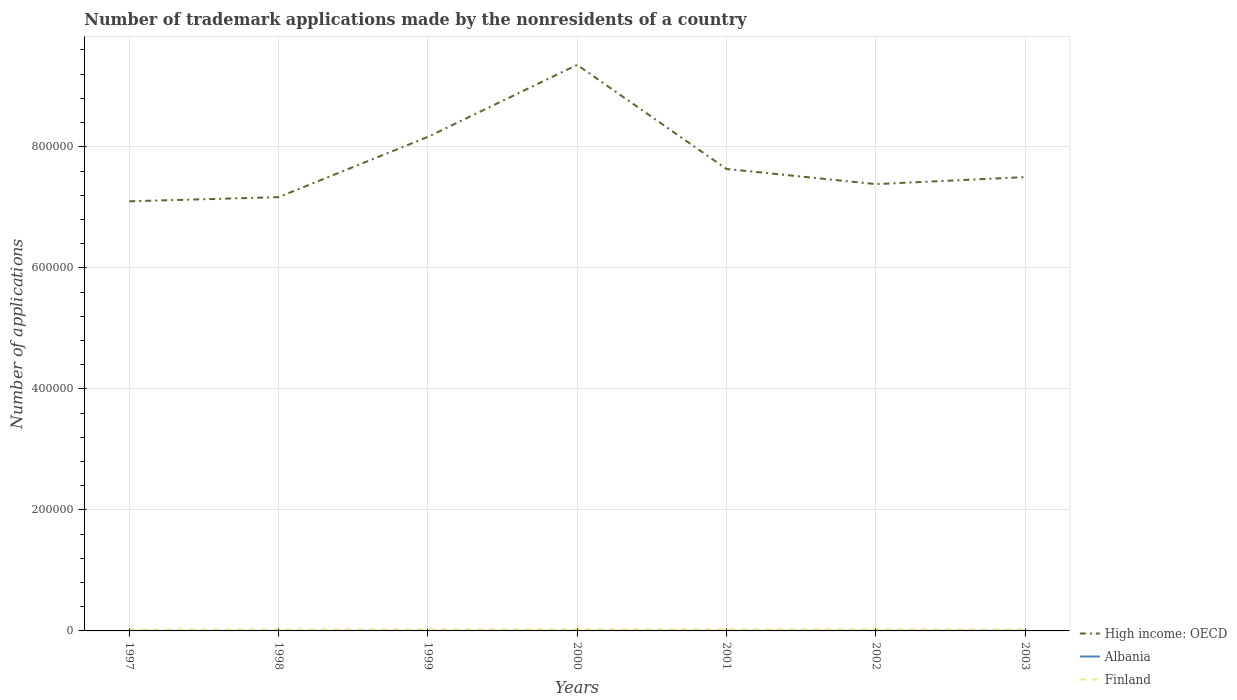How many different coloured lines are there?
Provide a succinct answer. 3. Across all years, what is the maximum number of trademark applications made by the nonresidents in Finland?
Offer a terse response. 2247. In which year was the number of trademark applications made by the nonresidents in Finland maximum?
Offer a terse response. 1997. What is the total number of trademark applications made by the nonresidents in High income: OECD in the graph?
Your answer should be compact. -2.25e+05. What is the difference between the highest and the second highest number of trademark applications made by the nonresidents in Albania?
Your answer should be compact. 115. Is the number of trademark applications made by the nonresidents in High income: OECD strictly greater than the number of trademark applications made by the nonresidents in Albania over the years?
Your answer should be compact. No. How many lines are there?
Offer a very short reply. 3. How many years are there in the graph?
Make the answer very short. 7. What is the difference between two consecutive major ticks on the Y-axis?
Ensure brevity in your answer.  2.00e+05. Are the values on the major ticks of Y-axis written in scientific E-notation?
Ensure brevity in your answer.  No. Does the graph contain grids?
Your answer should be compact. Yes. Where does the legend appear in the graph?
Your answer should be very brief. Bottom right. How many legend labels are there?
Provide a short and direct response. 3. What is the title of the graph?
Offer a terse response. Number of trademark applications made by the nonresidents of a country. Does "Kyrgyz Republic" appear as one of the legend labels in the graph?
Provide a succinct answer. No. What is the label or title of the X-axis?
Provide a succinct answer. Years. What is the label or title of the Y-axis?
Give a very brief answer. Number of applications. What is the Number of applications of High income: OECD in 1997?
Your answer should be compact. 7.10e+05. What is the Number of applications in Albania in 1997?
Your answer should be very brief. 36. What is the Number of applications of Finland in 1997?
Give a very brief answer. 2247. What is the Number of applications of High income: OECD in 1998?
Keep it short and to the point. 7.17e+05. What is the Number of applications of Finland in 1998?
Your answer should be compact. 2370. What is the Number of applications in High income: OECD in 1999?
Your response must be concise. 8.16e+05. What is the Number of applications in Albania in 1999?
Your response must be concise. 17. What is the Number of applications in Finland in 1999?
Your response must be concise. 2620. What is the Number of applications of High income: OECD in 2000?
Your answer should be very brief. 9.35e+05. What is the Number of applications in Albania in 2000?
Give a very brief answer. 32. What is the Number of applications of Finland in 2000?
Your answer should be compact. 2906. What is the Number of applications of High income: OECD in 2001?
Your answer should be very brief. 7.63e+05. What is the Number of applications in Finland in 2001?
Provide a succinct answer. 2879. What is the Number of applications in High income: OECD in 2002?
Provide a succinct answer. 7.38e+05. What is the Number of applications in Albania in 2002?
Keep it short and to the point. 106. What is the Number of applications of Finland in 2002?
Give a very brief answer. 2830. What is the Number of applications in High income: OECD in 2003?
Give a very brief answer. 7.50e+05. What is the Number of applications of Albania in 2003?
Keep it short and to the point. 132. What is the Number of applications in Finland in 2003?
Your response must be concise. 2456. Across all years, what is the maximum Number of applications of High income: OECD?
Your response must be concise. 9.35e+05. Across all years, what is the maximum Number of applications in Albania?
Provide a succinct answer. 132. Across all years, what is the maximum Number of applications in Finland?
Keep it short and to the point. 2906. Across all years, what is the minimum Number of applications of High income: OECD?
Your answer should be compact. 7.10e+05. Across all years, what is the minimum Number of applications in Finland?
Your answer should be very brief. 2247. What is the total Number of applications in High income: OECD in the graph?
Give a very brief answer. 5.43e+06. What is the total Number of applications of Albania in the graph?
Provide a succinct answer. 404. What is the total Number of applications in Finland in the graph?
Offer a very short reply. 1.83e+04. What is the difference between the Number of applications in High income: OECD in 1997 and that in 1998?
Make the answer very short. -6853. What is the difference between the Number of applications of Finland in 1997 and that in 1998?
Offer a very short reply. -123. What is the difference between the Number of applications in High income: OECD in 1997 and that in 1999?
Your answer should be compact. -1.06e+05. What is the difference between the Number of applications of Finland in 1997 and that in 1999?
Make the answer very short. -373. What is the difference between the Number of applications of High income: OECD in 1997 and that in 2000?
Keep it short and to the point. -2.25e+05. What is the difference between the Number of applications in Albania in 1997 and that in 2000?
Offer a terse response. 4. What is the difference between the Number of applications of Finland in 1997 and that in 2000?
Your answer should be very brief. -659. What is the difference between the Number of applications of High income: OECD in 1997 and that in 2001?
Your response must be concise. -5.35e+04. What is the difference between the Number of applications of Finland in 1997 and that in 2001?
Offer a terse response. -632. What is the difference between the Number of applications in High income: OECD in 1997 and that in 2002?
Provide a short and direct response. -2.84e+04. What is the difference between the Number of applications of Albania in 1997 and that in 2002?
Ensure brevity in your answer.  -70. What is the difference between the Number of applications in Finland in 1997 and that in 2002?
Provide a succinct answer. -583. What is the difference between the Number of applications in High income: OECD in 1997 and that in 2003?
Your answer should be compact. -4.00e+04. What is the difference between the Number of applications in Albania in 1997 and that in 2003?
Offer a very short reply. -96. What is the difference between the Number of applications of Finland in 1997 and that in 2003?
Provide a succinct answer. -209. What is the difference between the Number of applications of High income: OECD in 1998 and that in 1999?
Offer a terse response. -9.96e+04. What is the difference between the Number of applications in Albania in 1998 and that in 1999?
Make the answer very short. 10. What is the difference between the Number of applications in Finland in 1998 and that in 1999?
Offer a terse response. -250. What is the difference between the Number of applications in High income: OECD in 1998 and that in 2000?
Keep it short and to the point. -2.19e+05. What is the difference between the Number of applications in Albania in 1998 and that in 2000?
Your answer should be very brief. -5. What is the difference between the Number of applications of Finland in 1998 and that in 2000?
Provide a short and direct response. -536. What is the difference between the Number of applications in High income: OECD in 1998 and that in 2001?
Provide a short and direct response. -4.66e+04. What is the difference between the Number of applications in Albania in 1998 and that in 2001?
Offer a terse response. -27. What is the difference between the Number of applications in Finland in 1998 and that in 2001?
Keep it short and to the point. -509. What is the difference between the Number of applications in High income: OECD in 1998 and that in 2002?
Make the answer very short. -2.16e+04. What is the difference between the Number of applications in Albania in 1998 and that in 2002?
Your answer should be very brief. -79. What is the difference between the Number of applications of Finland in 1998 and that in 2002?
Your response must be concise. -460. What is the difference between the Number of applications of High income: OECD in 1998 and that in 2003?
Make the answer very short. -3.32e+04. What is the difference between the Number of applications of Albania in 1998 and that in 2003?
Provide a succinct answer. -105. What is the difference between the Number of applications of Finland in 1998 and that in 2003?
Keep it short and to the point. -86. What is the difference between the Number of applications in High income: OECD in 1999 and that in 2000?
Your response must be concise. -1.19e+05. What is the difference between the Number of applications in Albania in 1999 and that in 2000?
Your answer should be very brief. -15. What is the difference between the Number of applications in Finland in 1999 and that in 2000?
Your answer should be very brief. -286. What is the difference between the Number of applications in High income: OECD in 1999 and that in 2001?
Offer a terse response. 5.30e+04. What is the difference between the Number of applications in Albania in 1999 and that in 2001?
Your answer should be very brief. -37. What is the difference between the Number of applications in Finland in 1999 and that in 2001?
Your response must be concise. -259. What is the difference between the Number of applications of High income: OECD in 1999 and that in 2002?
Keep it short and to the point. 7.80e+04. What is the difference between the Number of applications of Albania in 1999 and that in 2002?
Give a very brief answer. -89. What is the difference between the Number of applications in Finland in 1999 and that in 2002?
Keep it short and to the point. -210. What is the difference between the Number of applications in High income: OECD in 1999 and that in 2003?
Make the answer very short. 6.64e+04. What is the difference between the Number of applications in Albania in 1999 and that in 2003?
Provide a succinct answer. -115. What is the difference between the Number of applications of Finland in 1999 and that in 2003?
Your response must be concise. 164. What is the difference between the Number of applications in High income: OECD in 2000 and that in 2001?
Give a very brief answer. 1.72e+05. What is the difference between the Number of applications in Finland in 2000 and that in 2001?
Offer a terse response. 27. What is the difference between the Number of applications of High income: OECD in 2000 and that in 2002?
Your response must be concise. 1.97e+05. What is the difference between the Number of applications in Albania in 2000 and that in 2002?
Your answer should be very brief. -74. What is the difference between the Number of applications in Finland in 2000 and that in 2002?
Provide a short and direct response. 76. What is the difference between the Number of applications in High income: OECD in 2000 and that in 2003?
Offer a terse response. 1.85e+05. What is the difference between the Number of applications in Albania in 2000 and that in 2003?
Offer a very short reply. -100. What is the difference between the Number of applications of Finland in 2000 and that in 2003?
Your response must be concise. 450. What is the difference between the Number of applications in High income: OECD in 2001 and that in 2002?
Give a very brief answer. 2.51e+04. What is the difference between the Number of applications of Albania in 2001 and that in 2002?
Offer a terse response. -52. What is the difference between the Number of applications in High income: OECD in 2001 and that in 2003?
Make the answer very short. 1.35e+04. What is the difference between the Number of applications in Albania in 2001 and that in 2003?
Your answer should be very brief. -78. What is the difference between the Number of applications in Finland in 2001 and that in 2003?
Your answer should be compact. 423. What is the difference between the Number of applications in High income: OECD in 2002 and that in 2003?
Make the answer very short. -1.16e+04. What is the difference between the Number of applications in Albania in 2002 and that in 2003?
Your answer should be very brief. -26. What is the difference between the Number of applications in Finland in 2002 and that in 2003?
Your response must be concise. 374. What is the difference between the Number of applications of High income: OECD in 1997 and the Number of applications of Albania in 1998?
Offer a terse response. 7.10e+05. What is the difference between the Number of applications of High income: OECD in 1997 and the Number of applications of Finland in 1998?
Your response must be concise. 7.08e+05. What is the difference between the Number of applications in Albania in 1997 and the Number of applications in Finland in 1998?
Offer a very short reply. -2334. What is the difference between the Number of applications in High income: OECD in 1997 and the Number of applications in Albania in 1999?
Your response must be concise. 7.10e+05. What is the difference between the Number of applications in High income: OECD in 1997 and the Number of applications in Finland in 1999?
Keep it short and to the point. 7.07e+05. What is the difference between the Number of applications of Albania in 1997 and the Number of applications of Finland in 1999?
Make the answer very short. -2584. What is the difference between the Number of applications in High income: OECD in 1997 and the Number of applications in Albania in 2000?
Make the answer very short. 7.10e+05. What is the difference between the Number of applications in High income: OECD in 1997 and the Number of applications in Finland in 2000?
Provide a short and direct response. 7.07e+05. What is the difference between the Number of applications of Albania in 1997 and the Number of applications of Finland in 2000?
Offer a very short reply. -2870. What is the difference between the Number of applications of High income: OECD in 1997 and the Number of applications of Albania in 2001?
Give a very brief answer. 7.10e+05. What is the difference between the Number of applications in High income: OECD in 1997 and the Number of applications in Finland in 2001?
Your answer should be very brief. 7.07e+05. What is the difference between the Number of applications in Albania in 1997 and the Number of applications in Finland in 2001?
Provide a succinct answer. -2843. What is the difference between the Number of applications in High income: OECD in 1997 and the Number of applications in Albania in 2002?
Your answer should be very brief. 7.10e+05. What is the difference between the Number of applications of High income: OECD in 1997 and the Number of applications of Finland in 2002?
Give a very brief answer. 7.07e+05. What is the difference between the Number of applications in Albania in 1997 and the Number of applications in Finland in 2002?
Provide a succinct answer. -2794. What is the difference between the Number of applications of High income: OECD in 1997 and the Number of applications of Albania in 2003?
Offer a very short reply. 7.10e+05. What is the difference between the Number of applications of High income: OECD in 1997 and the Number of applications of Finland in 2003?
Ensure brevity in your answer.  7.07e+05. What is the difference between the Number of applications in Albania in 1997 and the Number of applications in Finland in 2003?
Your answer should be very brief. -2420. What is the difference between the Number of applications in High income: OECD in 1998 and the Number of applications in Albania in 1999?
Your answer should be compact. 7.17e+05. What is the difference between the Number of applications of High income: OECD in 1998 and the Number of applications of Finland in 1999?
Your response must be concise. 7.14e+05. What is the difference between the Number of applications of Albania in 1998 and the Number of applications of Finland in 1999?
Your answer should be compact. -2593. What is the difference between the Number of applications of High income: OECD in 1998 and the Number of applications of Albania in 2000?
Provide a short and direct response. 7.17e+05. What is the difference between the Number of applications in High income: OECD in 1998 and the Number of applications in Finland in 2000?
Offer a terse response. 7.14e+05. What is the difference between the Number of applications in Albania in 1998 and the Number of applications in Finland in 2000?
Keep it short and to the point. -2879. What is the difference between the Number of applications of High income: OECD in 1998 and the Number of applications of Albania in 2001?
Your answer should be very brief. 7.17e+05. What is the difference between the Number of applications of High income: OECD in 1998 and the Number of applications of Finland in 2001?
Make the answer very short. 7.14e+05. What is the difference between the Number of applications of Albania in 1998 and the Number of applications of Finland in 2001?
Provide a succinct answer. -2852. What is the difference between the Number of applications in High income: OECD in 1998 and the Number of applications in Albania in 2002?
Your answer should be compact. 7.17e+05. What is the difference between the Number of applications of High income: OECD in 1998 and the Number of applications of Finland in 2002?
Your answer should be very brief. 7.14e+05. What is the difference between the Number of applications in Albania in 1998 and the Number of applications in Finland in 2002?
Your answer should be compact. -2803. What is the difference between the Number of applications in High income: OECD in 1998 and the Number of applications in Albania in 2003?
Provide a succinct answer. 7.17e+05. What is the difference between the Number of applications in High income: OECD in 1998 and the Number of applications in Finland in 2003?
Your answer should be compact. 7.14e+05. What is the difference between the Number of applications of Albania in 1998 and the Number of applications of Finland in 2003?
Give a very brief answer. -2429. What is the difference between the Number of applications in High income: OECD in 1999 and the Number of applications in Albania in 2000?
Provide a short and direct response. 8.16e+05. What is the difference between the Number of applications in High income: OECD in 1999 and the Number of applications in Finland in 2000?
Offer a terse response. 8.13e+05. What is the difference between the Number of applications in Albania in 1999 and the Number of applications in Finland in 2000?
Ensure brevity in your answer.  -2889. What is the difference between the Number of applications in High income: OECD in 1999 and the Number of applications in Albania in 2001?
Ensure brevity in your answer.  8.16e+05. What is the difference between the Number of applications in High income: OECD in 1999 and the Number of applications in Finland in 2001?
Give a very brief answer. 8.14e+05. What is the difference between the Number of applications of Albania in 1999 and the Number of applications of Finland in 2001?
Provide a succinct answer. -2862. What is the difference between the Number of applications in High income: OECD in 1999 and the Number of applications in Albania in 2002?
Make the answer very short. 8.16e+05. What is the difference between the Number of applications of High income: OECD in 1999 and the Number of applications of Finland in 2002?
Keep it short and to the point. 8.14e+05. What is the difference between the Number of applications of Albania in 1999 and the Number of applications of Finland in 2002?
Offer a very short reply. -2813. What is the difference between the Number of applications in High income: OECD in 1999 and the Number of applications in Albania in 2003?
Give a very brief answer. 8.16e+05. What is the difference between the Number of applications in High income: OECD in 1999 and the Number of applications in Finland in 2003?
Make the answer very short. 8.14e+05. What is the difference between the Number of applications of Albania in 1999 and the Number of applications of Finland in 2003?
Your answer should be very brief. -2439. What is the difference between the Number of applications in High income: OECD in 2000 and the Number of applications in Albania in 2001?
Make the answer very short. 9.35e+05. What is the difference between the Number of applications in High income: OECD in 2000 and the Number of applications in Finland in 2001?
Offer a terse response. 9.33e+05. What is the difference between the Number of applications of Albania in 2000 and the Number of applications of Finland in 2001?
Your answer should be compact. -2847. What is the difference between the Number of applications of High income: OECD in 2000 and the Number of applications of Albania in 2002?
Make the answer very short. 9.35e+05. What is the difference between the Number of applications in High income: OECD in 2000 and the Number of applications in Finland in 2002?
Your answer should be very brief. 9.33e+05. What is the difference between the Number of applications of Albania in 2000 and the Number of applications of Finland in 2002?
Provide a short and direct response. -2798. What is the difference between the Number of applications in High income: OECD in 2000 and the Number of applications in Albania in 2003?
Offer a terse response. 9.35e+05. What is the difference between the Number of applications in High income: OECD in 2000 and the Number of applications in Finland in 2003?
Your answer should be compact. 9.33e+05. What is the difference between the Number of applications in Albania in 2000 and the Number of applications in Finland in 2003?
Make the answer very short. -2424. What is the difference between the Number of applications in High income: OECD in 2001 and the Number of applications in Albania in 2002?
Offer a terse response. 7.63e+05. What is the difference between the Number of applications of High income: OECD in 2001 and the Number of applications of Finland in 2002?
Offer a very short reply. 7.61e+05. What is the difference between the Number of applications in Albania in 2001 and the Number of applications in Finland in 2002?
Your response must be concise. -2776. What is the difference between the Number of applications of High income: OECD in 2001 and the Number of applications of Albania in 2003?
Make the answer very short. 7.63e+05. What is the difference between the Number of applications of High income: OECD in 2001 and the Number of applications of Finland in 2003?
Your answer should be very brief. 7.61e+05. What is the difference between the Number of applications of Albania in 2001 and the Number of applications of Finland in 2003?
Give a very brief answer. -2402. What is the difference between the Number of applications of High income: OECD in 2002 and the Number of applications of Albania in 2003?
Provide a short and direct response. 7.38e+05. What is the difference between the Number of applications of High income: OECD in 2002 and the Number of applications of Finland in 2003?
Your response must be concise. 7.36e+05. What is the difference between the Number of applications in Albania in 2002 and the Number of applications in Finland in 2003?
Offer a very short reply. -2350. What is the average Number of applications in High income: OECD per year?
Give a very brief answer. 7.76e+05. What is the average Number of applications in Albania per year?
Your response must be concise. 57.71. What is the average Number of applications of Finland per year?
Give a very brief answer. 2615.43. In the year 1997, what is the difference between the Number of applications of High income: OECD and Number of applications of Albania?
Make the answer very short. 7.10e+05. In the year 1997, what is the difference between the Number of applications in High income: OECD and Number of applications in Finland?
Your answer should be compact. 7.08e+05. In the year 1997, what is the difference between the Number of applications of Albania and Number of applications of Finland?
Your response must be concise. -2211. In the year 1998, what is the difference between the Number of applications of High income: OECD and Number of applications of Albania?
Offer a very short reply. 7.17e+05. In the year 1998, what is the difference between the Number of applications of High income: OECD and Number of applications of Finland?
Your response must be concise. 7.14e+05. In the year 1998, what is the difference between the Number of applications of Albania and Number of applications of Finland?
Provide a short and direct response. -2343. In the year 1999, what is the difference between the Number of applications of High income: OECD and Number of applications of Albania?
Make the answer very short. 8.16e+05. In the year 1999, what is the difference between the Number of applications of High income: OECD and Number of applications of Finland?
Your answer should be very brief. 8.14e+05. In the year 1999, what is the difference between the Number of applications in Albania and Number of applications in Finland?
Provide a succinct answer. -2603. In the year 2000, what is the difference between the Number of applications of High income: OECD and Number of applications of Albania?
Offer a very short reply. 9.35e+05. In the year 2000, what is the difference between the Number of applications in High income: OECD and Number of applications in Finland?
Offer a terse response. 9.32e+05. In the year 2000, what is the difference between the Number of applications of Albania and Number of applications of Finland?
Give a very brief answer. -2874. In the year 2001, what is the difference between the Number of applications in High income: OECD and Number of applications in Albania?
Ensure brevity in your answer.  7.63e+05. In the year 2001, what is the difference between the Number of applications of High income: OECD and Number of applications of Finland?
Provide a short and direct response. 7.61e+05. In the year 2001, what is the difference between the Number of applications in Albania and Number of applications in Finland?
Offer a terse response. -2825. In the year 2002, what is the difference between the Number of applications of High income: OECD and Number of applications of Albania?
Your response must be concise. 7.38e+05. In the year 2002, what is the difference between the Number of applications in High income: OECD and Number of applications in Finland?
Make the answer very short. 7.36e+05. In the year 2002, what is the difference between the Number of applications of Albania and Number of applications of Finland?
Your answer should be very brief. -2724. In the year 2003, what is the difference between the Number of applications of High income: OECD and Number of applications of Albania?
Make the answer very short. 7.50e+05. In the year 2003, what is the difference between the Number of applications of High income: OECD and Number of applications of Finland?
Make the answer very short. 7.47e+05. In the year 2003, what is the difference between the Number of applications in Albania and Number of applications in Finland?
Your answer should be very brief. -2324. What is the ratio of the Number of applications in High income: OECD in 1997 to that in 1998?
Your answer should be compact. 0.99. What is the ratio of the Number of applications of Albania in 1997 to that in 1998?
Ensure brevity in your answer.  1.33. What is the ratio of the Number of applications of Finland in 1997 to that in 1998?
Keep it short and to the point. 0.95. What is the ratio of the Number of applications of High income: OECD in 1997 to that in 1999?
Give a very brief answer. 0.87. What is the ratio of the Number of applications in Albania in 1997 to that in 1999?
Make the answer very short. 2.12. What is the ratio of the Number of applications of Finland in 1997 to that in 1999?
Your answer should be compact. 0.86. What is the ratio of the Number of applications in High income: OECD in 1997 to that in 2000?
Offer a terse response. 0.76. What is the ratio of the Number of applications in Finland in 1997 to that in 2000?
Offer a terse response. 0.77. What is the ratio of the Number of applications in Albania in 1997 to that in 2001?
Offer a very short reply. 0.67. What is the ratio of the Number of applications in Finland in 1997 to that in 2001?
Make the answer very short. 0.78. What is the ratio of the Number of applications in High income: OECD in 1997 to that in 2002?
Offer a terse response. 0.96. What is the ratio of the Number of applications of Albania in 1997 to that in 2002?
Ensure brevity in your answer.  0.34. What is the ratio of the Number of applications in Finland in 1997 to that in 2002?
Give a very brief answer. 0.79. What is the ratio of the Number of applications of High income: OECD in 1997 to that in 2003?
Your response must be concise. 0.95. What is the ratio of the Number of applications of Albania in 1997 to that in 2003?
Offer a very short reply. 0.27. What is the ratio of the Number of applications in Finland in 1997 to that in 2003?
Provide a succinct answer. 0.91. What is the ratio of the Number of applications in High income: OECD in 1998 to that in 1999?
Ensure brevity in your answer.  0.88. What is the ratio of the Number of applications in Albania in 1998 to that in 1999?
Give a very brief answer. 1.59. What is the ratio of the Number of applications in Finland in 1998 to that in 1999?
Your answer should be very brief. 0.9. What is the ratio of the Number of applications in High income: OECD in 1998 to that in 2000?
Your answer should be very brief. 0.77. What is the ratio of the Number of applications of Albania in 1998 to that in 2000?
Keep it short and to the point. 0.84. What is the ratio of the Number of applications in Finland in 1998 to that in 2000?
Make the answer very short. 0.82. What is the ratio of the Number of applications in High income: OECD in 1998 to that in 2001?
Your answer should be very brief. 0.94. What is the ratio of the Number of applications in Albania in 1998 to that in 2001?
Your answer should be compact. 0.5. What is the ratio of the Number of applications of Finland in 1998 to that in 2001?
Make the answer very short. 0.82. What is the ratio of the Number of applications of High income: OECD in 1998 to that in 2002?
Your response must be concise. 0.97. What is the ratio of the Number of applications of Albania in 1998 to that in 2002?
Make the answer very short. 0.25. What is the ratio of the Number of applications in Finland in 1998 to that in 2002?
Keep it short and to the point. 0.84. What is the ratio of the Number of applications of High income: OECD in 1998 to that in 2003?
Offer a terse response. 0.96. What is the ratio of the Number of applications in Albania in 1998 to that in 2003?
Make the answer very short. 0.2. What is the ratio of the Number of applications of High income: OECD in 1999 to that in 2000?
Offer a terse response. 0.87. What is the ratio of the Number of applications in Albania in 1999 to that in 2000?
Your answer should be very brief. 0.53. What is the ratio of the Number of applications of Finland in 1999 to that in 2000?
Provide a succinct answer. 0.9. What is the ratio of the Number of applications in High income: OECD in 1999 to that in 2001?
Keep it short and to the point. 1.07. What is the ratio of the Number of applications of Albania in 1999 to that in 2001?
Offer a very short reply. 0.31. What is the ratio of the Number of applications in Finland in 1999 to that in 2001?
Your response must be concise. 0.91. What is the ratio of the Number of applications of High income: OECD in 1999 to that in 2002?
Provide a succinct answer. 1.11. What is the ratio of the Number of applications of Albania in 1999 to that in 2002?
Keep it short and to the point. 0.16. What is the ratio of the Number of applications in Finland in 1999 to that in 2002?
Offer a very short reply. 0.93. What is the ratio of the Number of applications in High income: OECD in 1999 to that in 2003?
Your answer should be compact. 1.09. What is the ratio of the Number of applications of Albania in 1999 to that in 2003?
Give a very brief answer. 0.13. What is the ratio of the Number of applications of Finland in 1999 to that in 2003?
Make the answer very short. 1.07. What is the ratio of the Number of applications in High income: OECD in 2000 to that in 2001?
Offer a terse response. 1.23. What is the ratio of the Number of applications of Albania in 2000 to that in 2001?
Your answer should be compact. 0.59. What is the ratio of the Number of applications of Finland in 2000 to that in 2001?
Your response must be concise. 1.01. What is the ratio of the Number of applications of High income: OECD in 2000 to that in 2002?
Keep it short and to the point. 1.27. What is the ratio of the Number of applications in Albania in 2000 to that in 2002?
Offer a very short reply. 0.3. What is the ratio of the Number of applications in Finland in 2000 to that in 2002?
Offer a terse response. 1.03. What is the ratio of the Number of applications of High income: OECD in 2000 to that in 2003?
Give a very brief answer. 1.25. What is the ratio of the Number of applications in Albania in 2000 to that in 2003?
Your answer should be very brief. 0.24. What is the ratio of the Number of applications in Finland in 2000 to that in 2003?
Ensure brevity in your answer.  1.18. What is the ratio of the Number of applications in High income: OECD in 2001 to that in 2002?
Give a very brief answer. 1.03. What is the ratio of the Number of applications of Albania in 2001 to that in 2002?
Ensure brevity in your answer.  0.51. What is the ratio of the Number of applications in Finland in 2001 to that in 2002?
Give a very brief answer. 1.02. What is the ratio of the Number of applications of High income: OECD in 2001 to that in 2003?
Keep it short and to the point. 1.02. What is the ratio of the Number of applications in Albania in 2001 to that in 2003?
Make the answer very short. 0.41. What is the ratio of the Number of applications of Finland in 2001 to that in 2003?
Your answer should be very brief. 1.17. What is the ratio of the Number of applications in High income: OECD in 2002 to that in 2003?
Your answer should be compact. 0.98. What is the ratio of the Number of applications of Albania in 2002 to that in 2003?
Your answer should be very brief. 0.8. What is the ratio of the Number of applications in Finland in 2002 to that in 2003?
Offer a terse response. 1.15. What is the difference between the highest and the second highest Number of applications in High income: OECD?
Provide a succinct answer. 1.19e+05. What is the difference between the highest and the lowest Number of applications of High income: OECD?
Ensure brevity in your answer.  2.25e+05. What is the difference between the highest and the lowest Number of applications of Albania?
Make the answer very short. 115. What is the difference between the highest and the lowest Number of applications in Finland?
Your answer should be very brief. 659. 